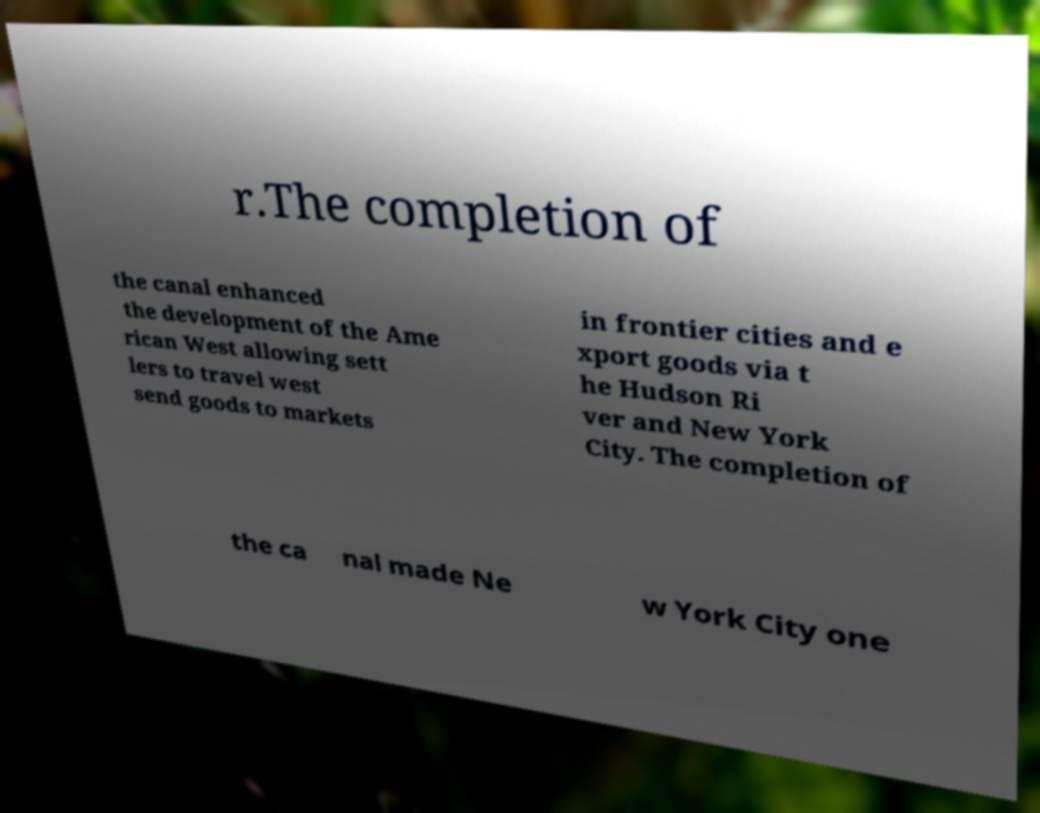For documentation purposes, I need the text within this image transcribed. Could you provide that? r.The completion of the canal enhanced the development of the Ame rican West allowing sett lers to travel west send goods to markets in frontier cities and e xport goods via t he Hudson Ri ver and New York City. The completion of the ca nal made Ne w York City one 